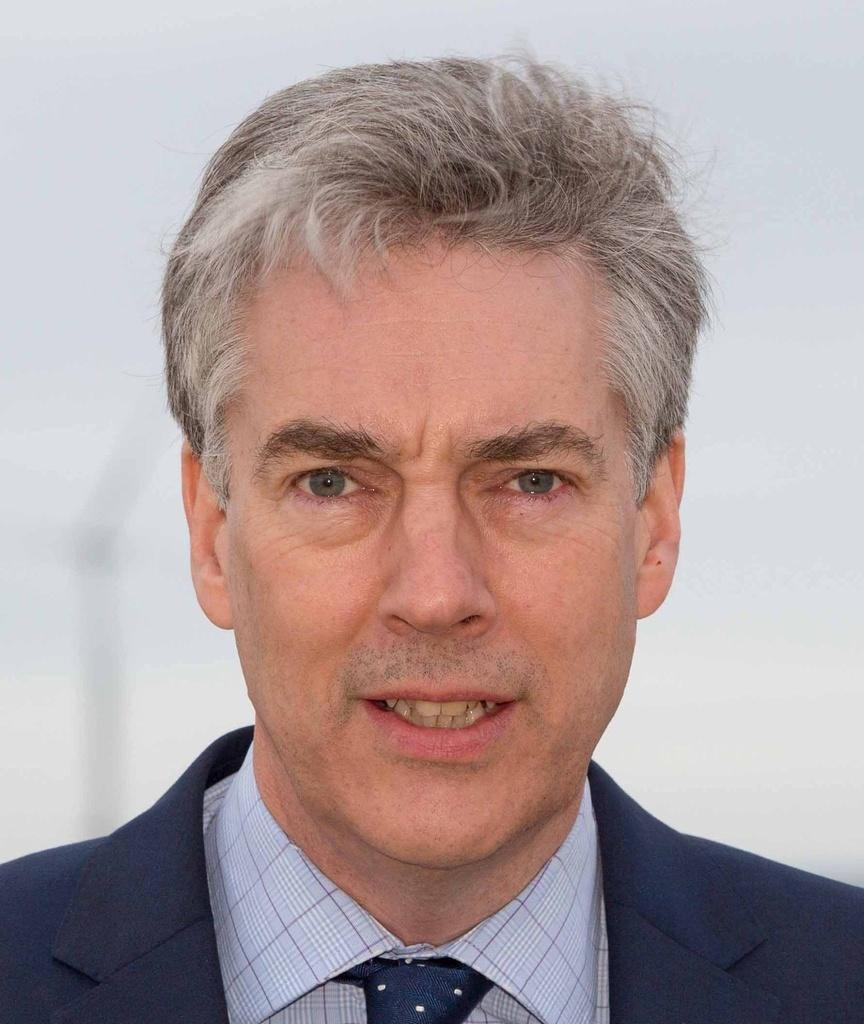Describe this image in one or two sentences. In the picture we can see a man wearing a blazer, shirt and a tie which is blue in color with a dot to it and he is having a white hair with black shade and in the background there is white in color. 